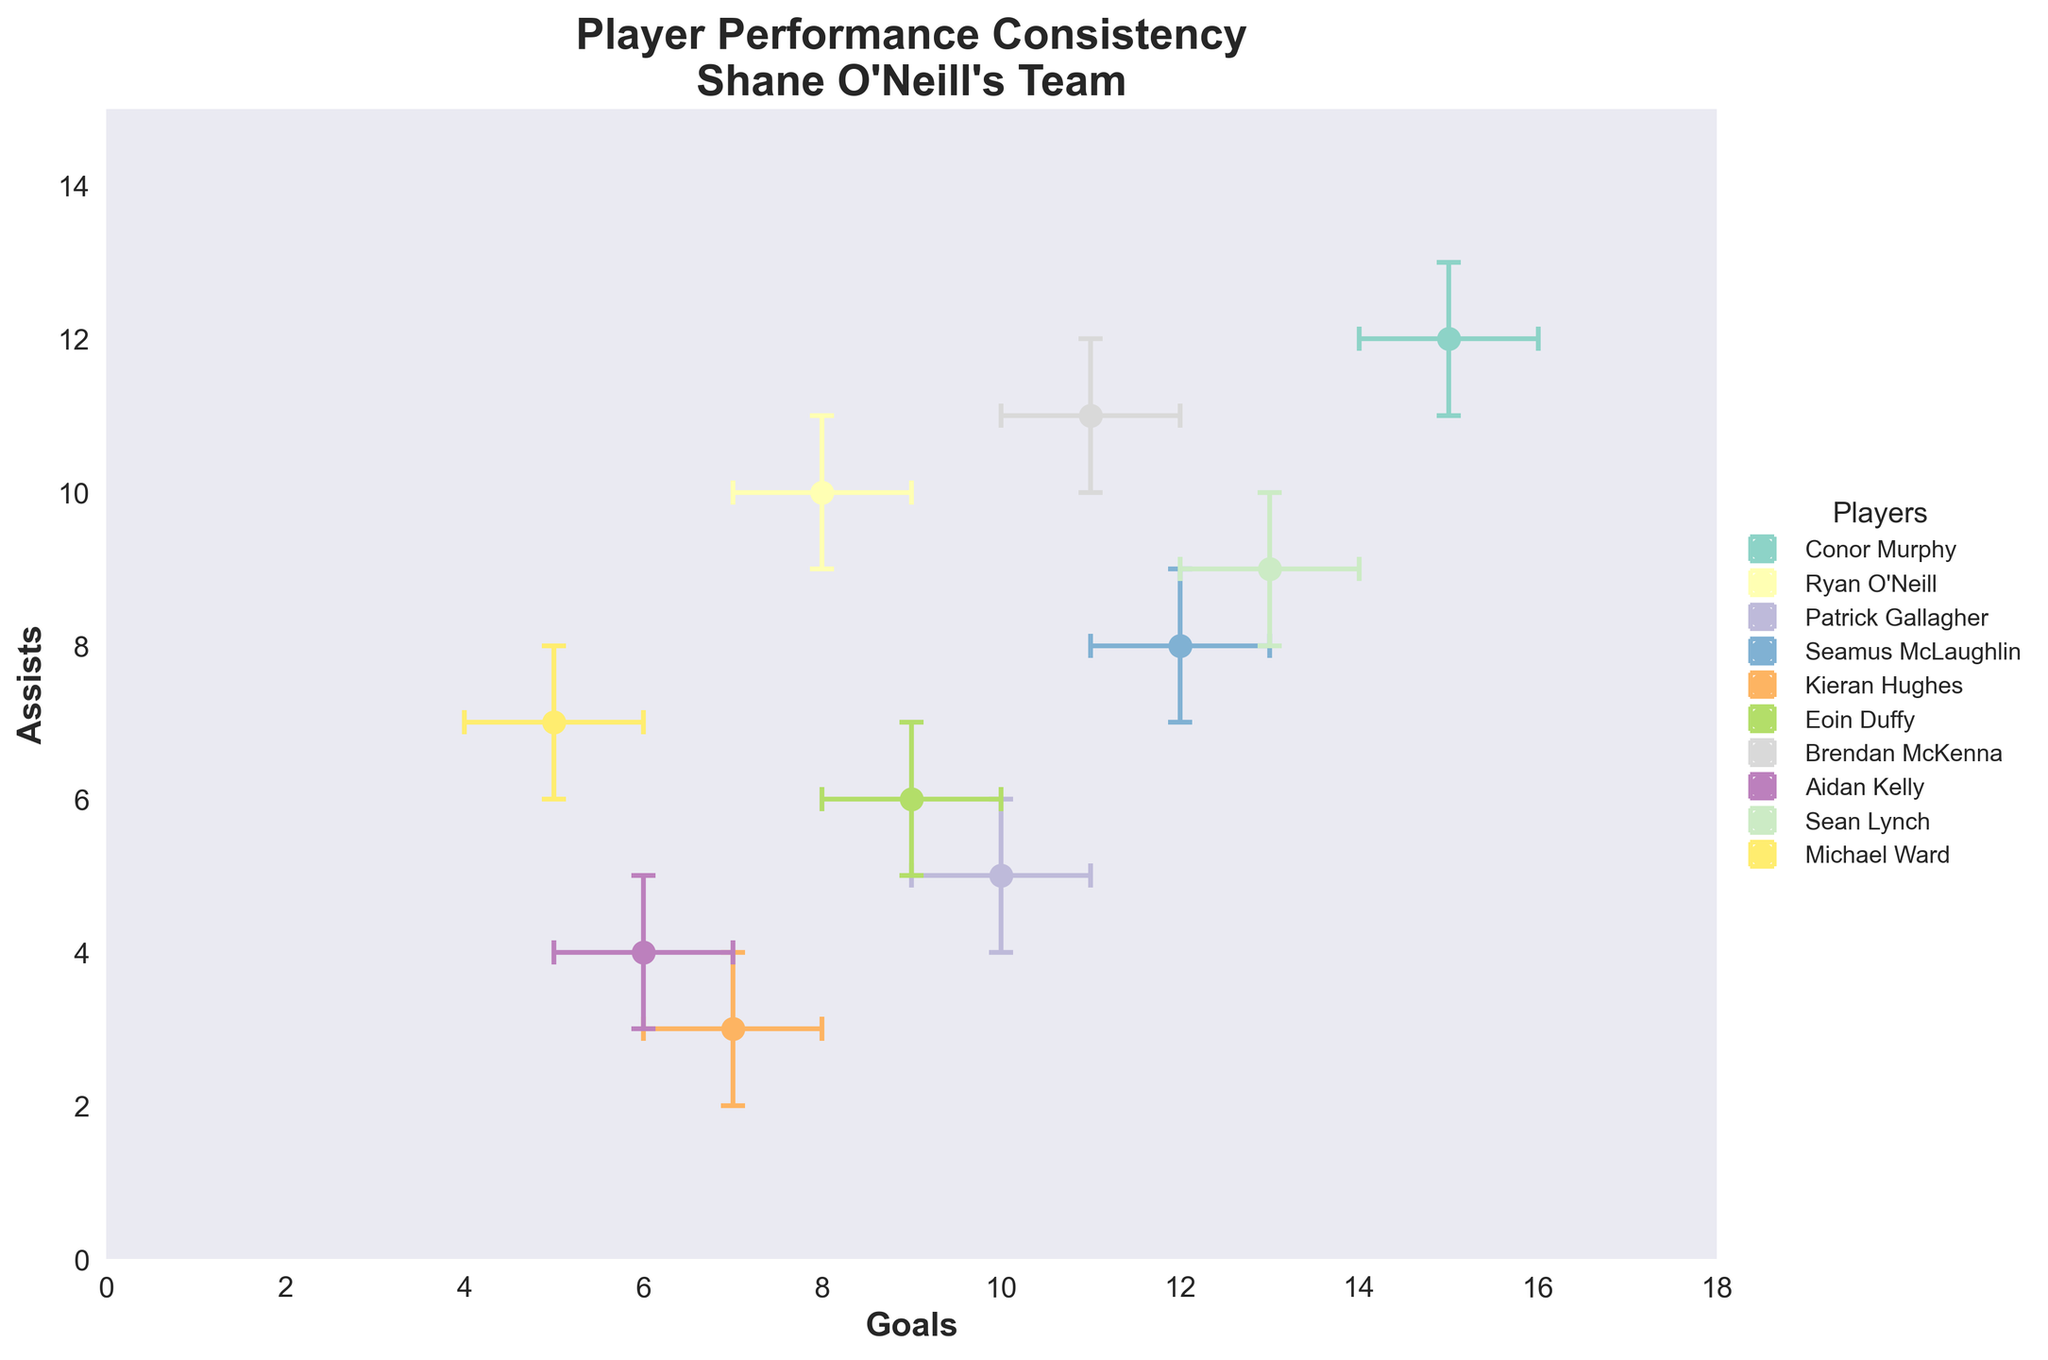How many players are shown in the scatter plot? The scatter plot includes error bars for each player. To count the number of players, we look at the number of different points with their respective error bars.
Answer: 10 Which player has the highest number of goals? To find the player with the highest number of goals, locate the point farthest to the right. According to the dataset, Conor Murphy scores the highest with 15 goals.
Answer: Conor Murphy Who has more assists, Ryan O'Neill or Kieran Hughes? Compare the positions of Ryan O'Neill and Kieran Hughes on the y-axis (Assists). Ryan O'Neill has 10 assists, while Kieran Hughes has 3 assists.
Answer: Ryan O'Neill What is the range (difference between the upper and lower bounds) of error bars for assists of Michael Ward? Michael Ward's assists range between 6 and 8, so the range of the error bars for his assists is calculated as 8 - 6.
Answer: 2 How many players have an overlapping confidence interval in the number of goals scored with Eoin Duffy? Eoin Duffy's confidence interval for goals is 8 to 10. We need to count how many other players have intervals that overlap with this range. Sean Lynch (12-14), Aidan Kelly (5-7), Brendan McKenna (10-12), Seamus McLaughlin (11-13), Patrick Gallagher (9-11), and Ryan O'Neill (7-9) all have ranges overlapping with Eoin Duffy's goals.
Answer: 6 Which player has the narrowest confidence interval for assists? Find the player whose vertical error bars (representing the assists' confidence interval) are the shortest. Ryan O'Neill's interval for assists is 9 to 11, having a range of 2, which is the smallest.
Answer: Ryan O'Neill Which player has the most consistent performance (smallest goals and assists error ranges combined)? To determine the most consistent performer, examine the total error range (both goals and assists) for each player. Calculate the sums: Conor Murphy: (16-14) + (13-11)=4, Ryan O'Neill: (9-7) + (11-9)=4, Patrick Gallagher: (11-9) + (6-4)=4, Seamus McLaughlin: (13-11) + (9-7)=4, Kieran Hughes: (8-6) + (4-2)=4, Eoin Duffy: (10-8) + (7-5)=4, Brendan McKenna: (12-10) + (12-10)=4, Aidan Kelly: (7-5) + (5-3)=4, Sean Lynch: (14-12) + (10-8)=4, Michael Ward: (6-4) + (8-6)=4. All players have the same total error range.
Answer: All players have the same consistency Which players have a higher upper confidence interval for goals than Brendan McKenna? Brendan McKenna's upper confidence interval for goals is 12. Check which players have a higher upper interval. Conor Murphy (16), Seamus McLaughlin (13), Sean Lynch (14) all have higher upper intervals.
Answer: Conor Murphy, Seamus McLaughlin, Sean Lynch 